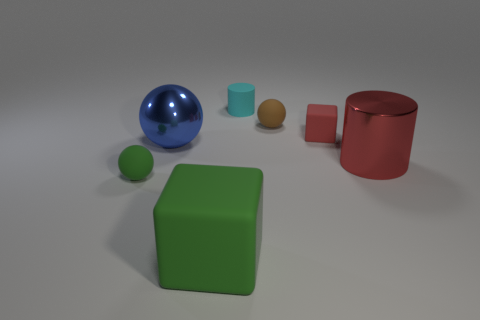Subtract all tiny brown rubber balls. How many balls are left? 2 Add 2 small purple spheres. How many objects exist? 9 Subtract all cylinders. How many objects are left? 5 Add 6 red metal cylinders. How many red metal cylinders are left? 7 Add 1 tiny purple blocks. How many tiny purple blocks exist? 1 Subtract 1 green blocks. How many objects are left? 6 Subtract all red cylinders. Subtract all blue spheres. How many cylinders are left? 1 Subtract all tiny rubber balls. Subtract all green blocks. How many objects are left? 4 